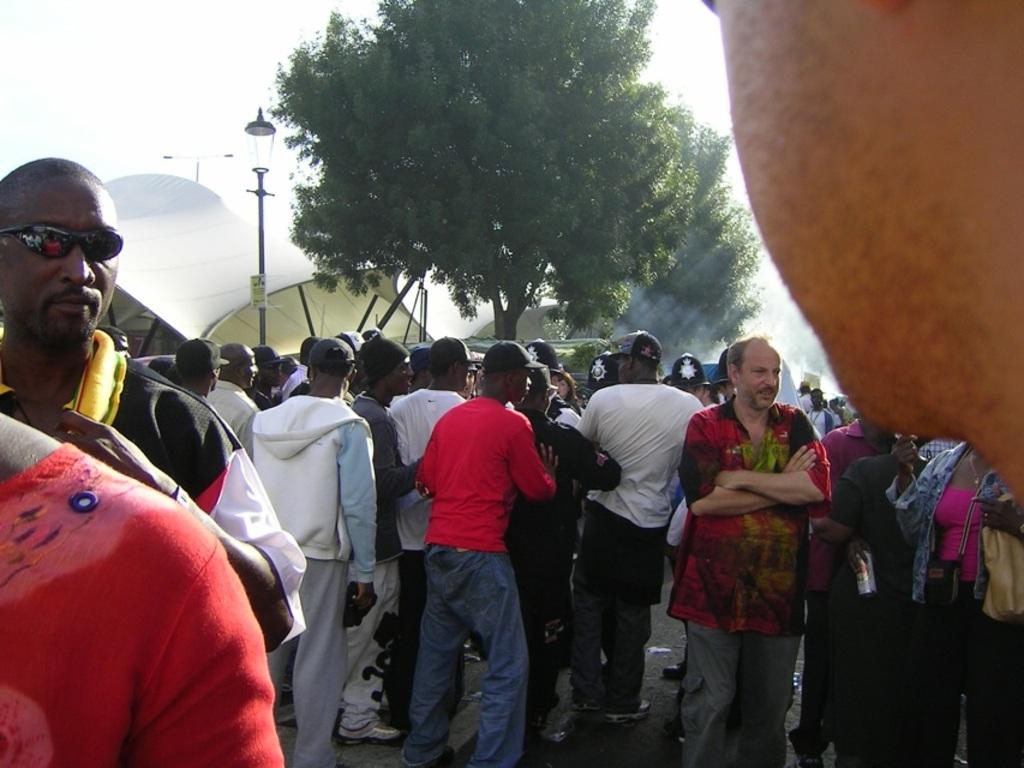What are the persons in the image doing? The persons in the image are standing in a group. What type of clothing are the persons wearing? The persons are wearing sweaters and caps. What can be seen in the background of the image? There are trees, lights, tents, and a clear sky visible in the background of the image. How does the beggar in the image receive support from the group? There is no beggar present in the image; it features a group of persons standing together. 